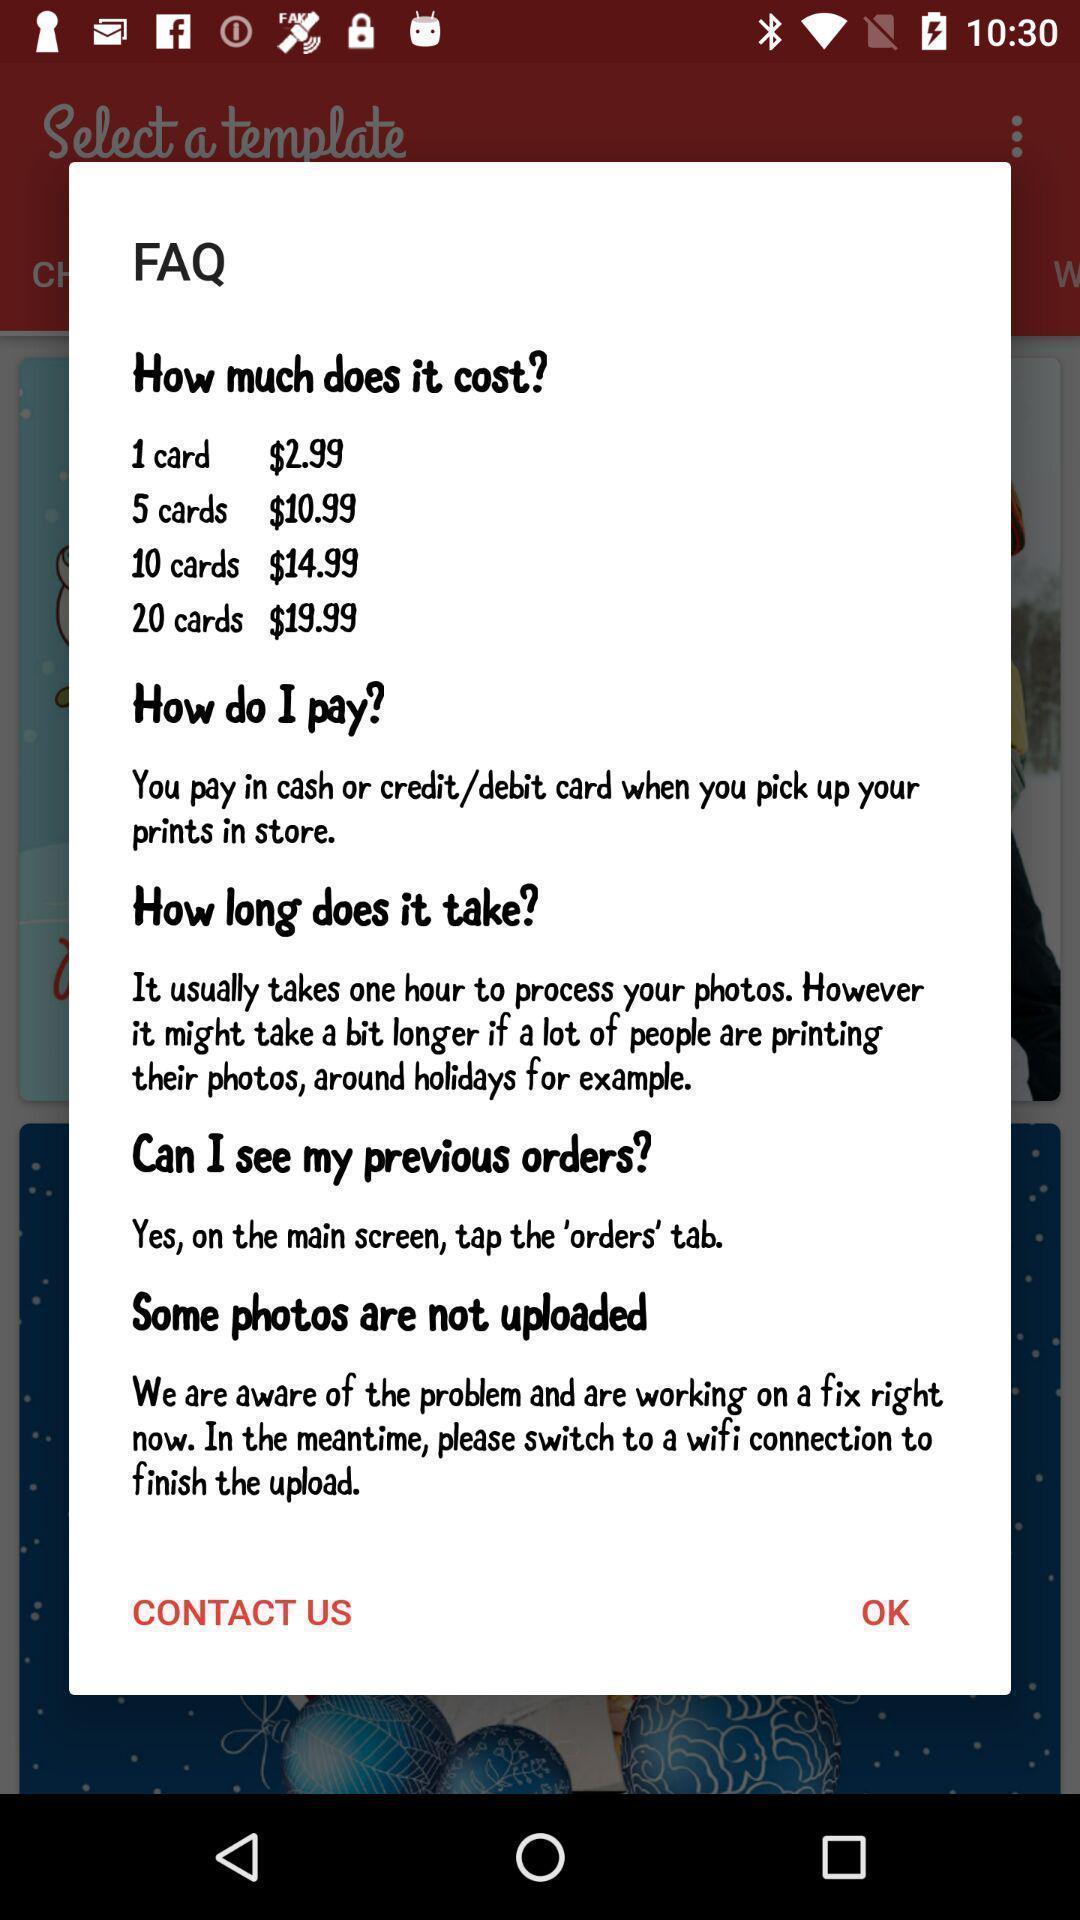Describe the key features of this screenshot. Pop-up showing information about payment. 